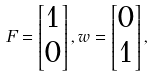Convert formula to latex. <formula><loc_0><loc_0><loc_500><loc_500>F = \begin{bmatrix} 1 \\ 0 \end{bmatrix} , w = \begin{bmatrix} 0 \\ 1 \end{bmatrix} ,</formula> 